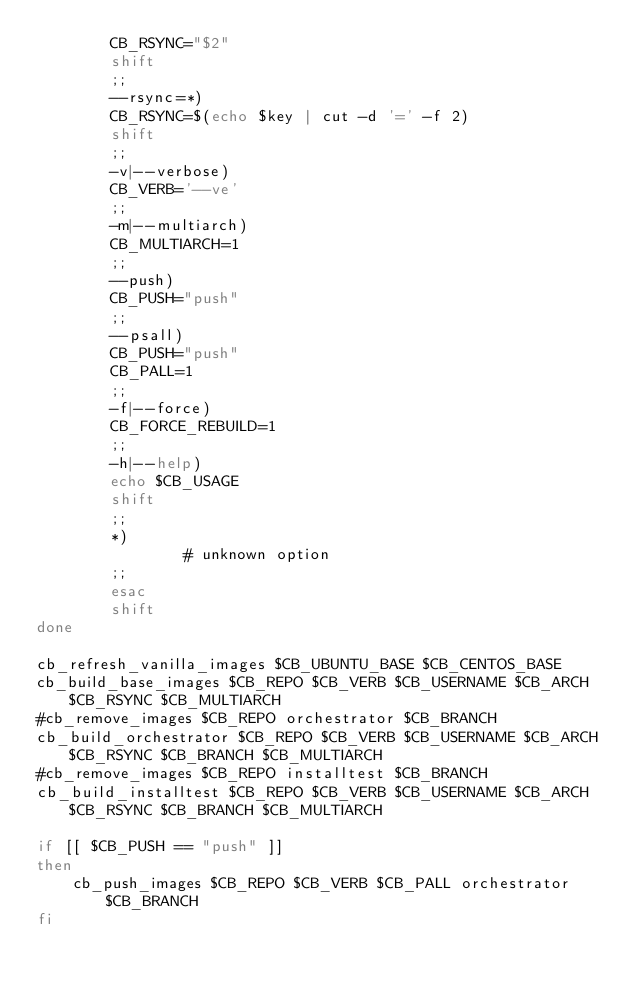<code> <loc_0><loc_0><loc_500><loc_500><_Bash_>        CB_RSYNC="$2"
        shift
        ;;
        --rsync=*)
        CB_RSYNC=$(echo $key | cut -d '=' -f 2)
        shift
        ;;                     
        -v|--verbose)
        CB_VERB='--ve'
        ;;
        -m|--multiarch)
        CB_MULTIARCH=1
        ;;        
        --push)
        CB_PUSH="push"
        ;;
        --psall)
        CB_PUSH="push"
        CB_PALL=1
        ;;
        -f|--force)
        CB_FORCE_REBUILD=1
        ;;        
        -h|--help)
        echo $CB_USAGE
        shift
        ;;
        *)
                # unknown option
        ;;
        esac
        shift
done

cb_refresh_vanilla_images $CB_UBUNTU_BASE $CB_CENTOS_BASE
cb_build_base_images $CB_REPO $CB_VERB $CB_USERNAME $CB_ARCH $CB_RSYNC $CB_MULTIARCH
#cb_remove_images $CB_REPO orchestrator $CB_BRANCH
cb_build_orchestrator $CB_REPO $CB_VERB $CB_USERNAME $CB_ARCH $CB_RSYNC $CB_BRANCH $CB_MULTIARCH
#cb_remove_images $CB_REPO installtest $CB_BRANCH
cb_build_installtest $CB_REPO $CB_VERB $CB_USERNAME $CB_ARCH $CB_RSYNC $CB_BRANCH $CB_MULTIARCH

if [[ $CB_PUSH == "push" ]]
then
    cb_push_images $CB_REPO $CB_VERB $CB_PALL orchestrator $CB_BRANCH
fi
</code> 